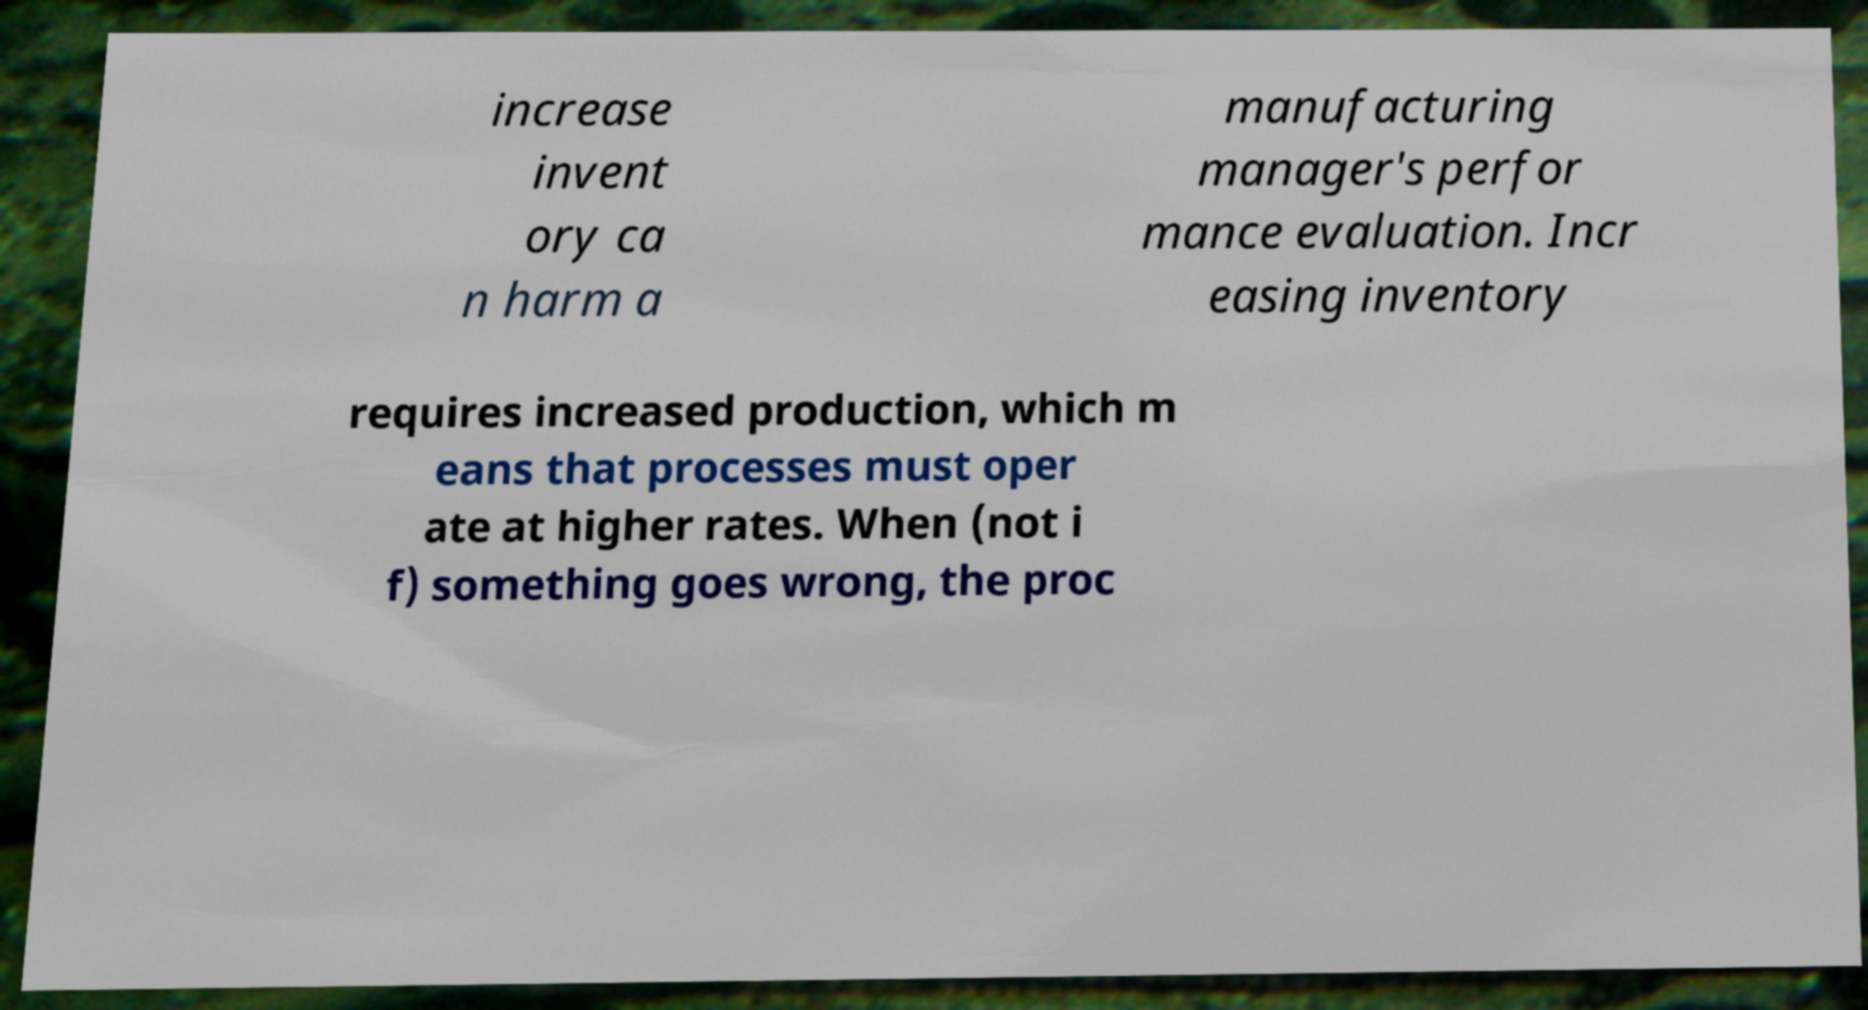For documentation purposes, I need the text within this image transcribed. Could you provide that? increase invent ory ca n harm a manufacturing manager's perfor mance evaluation. Incr easing inventory requires increased production, which m eans that processes must oper ate at higher rates. When (not i f) something goes wrong, the proc 